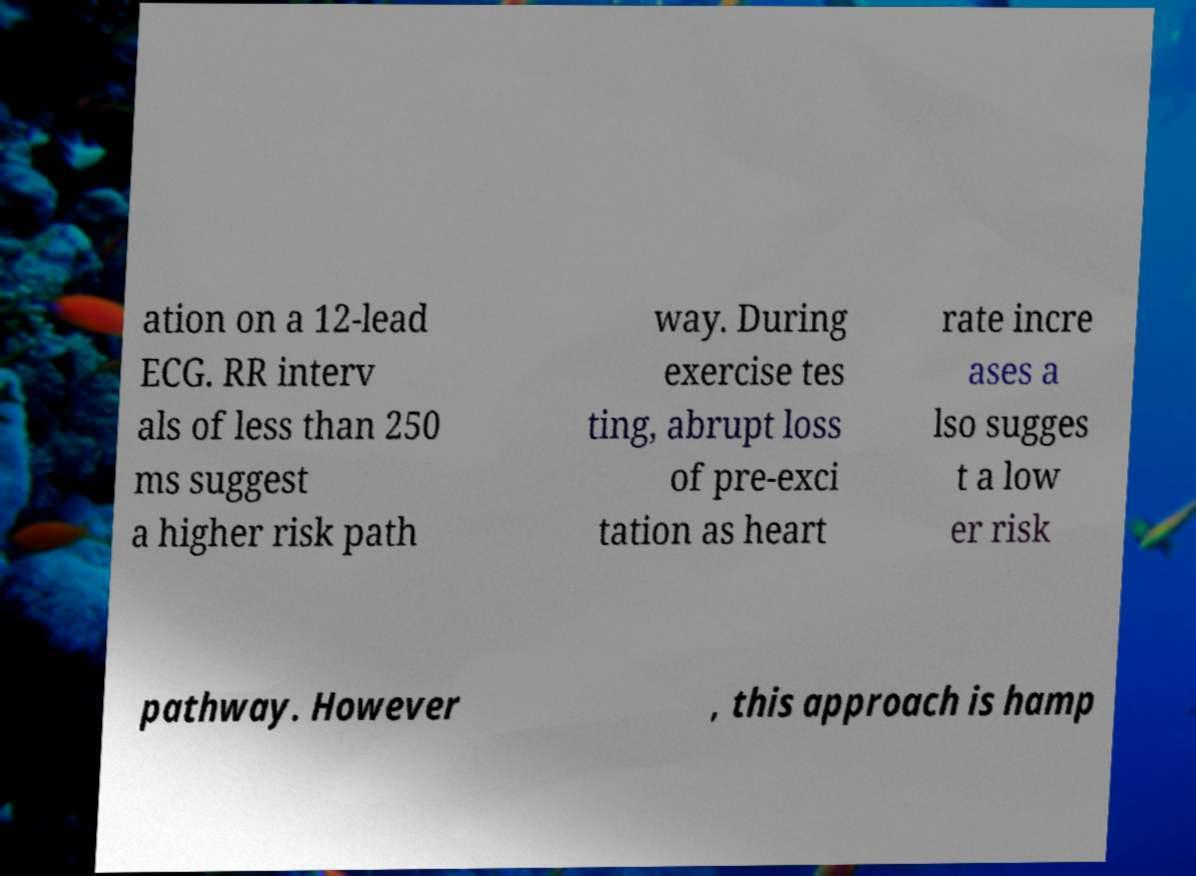Could you assist in decoding the text presented in this image and type it out clearly? ation on a 12-lead ECG. RR interv als of less than 250 ms suggest a higher risk path way. During exercise tes ting, abrupt loss of pre-exci tation as heart rate incre ases a lso sugges t a low er risk pathway. However , this approach is hamp 